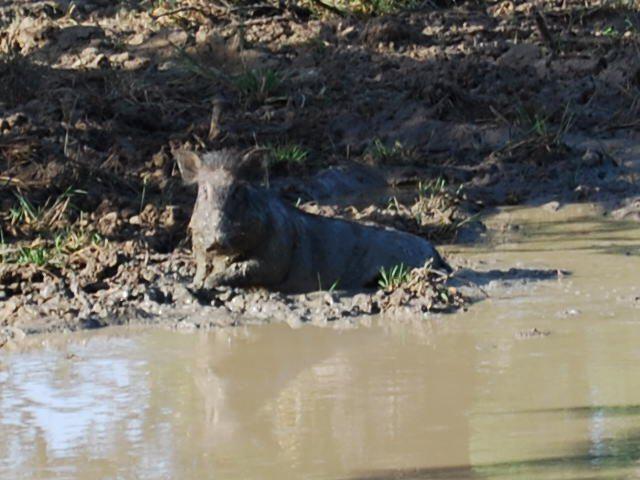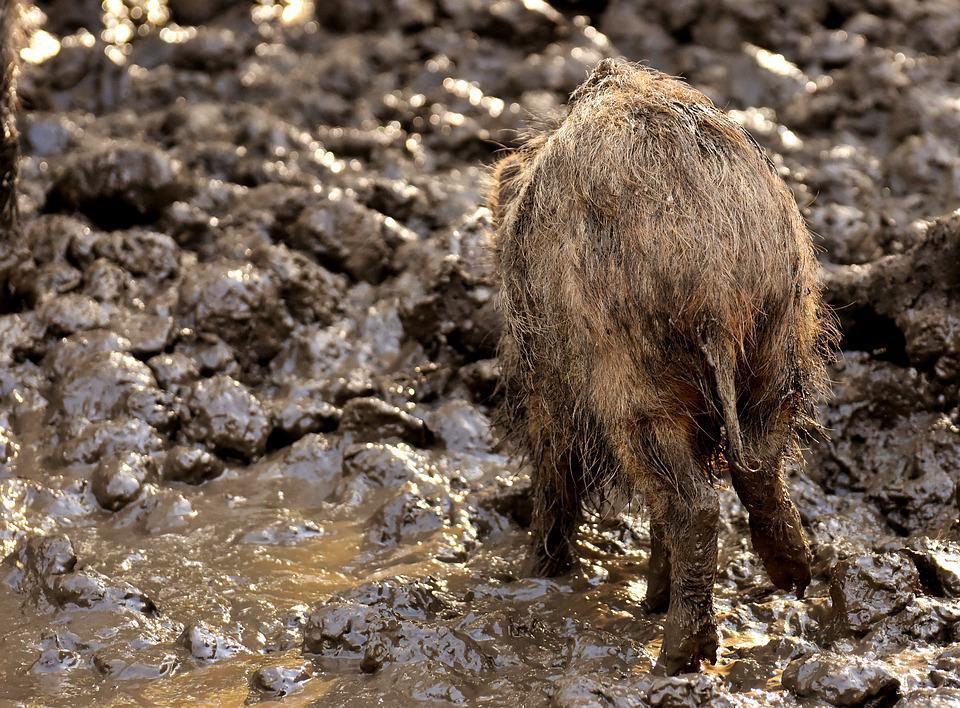The first image is the image on the left, the second image is the image on the right. Evaluate the accuracy of this statement regarding the images: "In at least one image there is a hog in the mud whose body is facing left while they rest.". Is it true? Answer yes or no. Yes. 